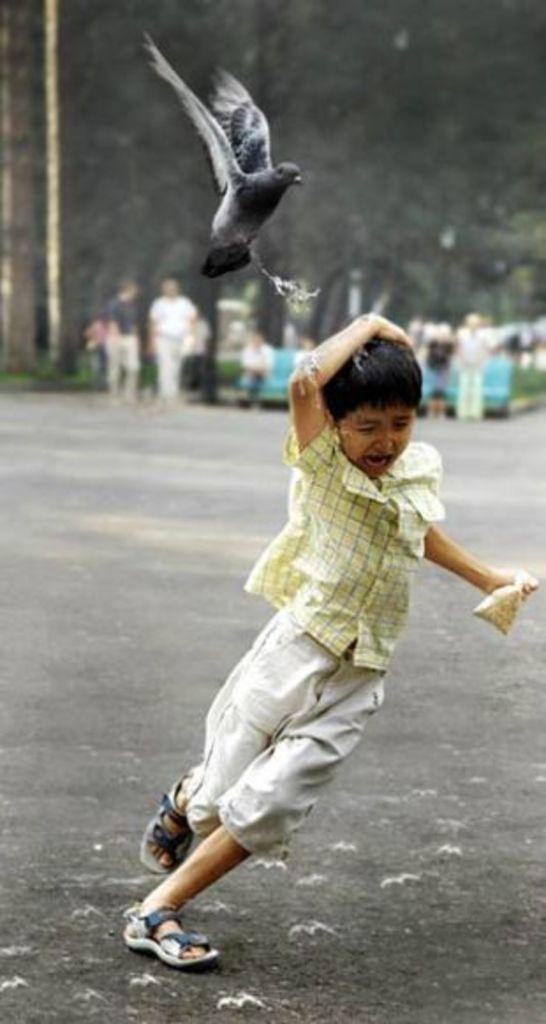What is the main subject of the image? The main subject of the image is a boy. What is the boy doing in the image? The boy is running on the road. What other living creature is present in the image? There is a bird in the image. Where is the bird located in relation to the boy? The bird is above the boy. What action is the bird performing in the image? The bird is emitting its excrement on the boy. Can you describe the background of the image? There are people standing in the background of the image. What type of meal is the boy eating in the image? There is no meal present in the image; the boy is running on the road. Can you describe the bedroom where the boy is sleeping in the image? There is no bedroom or sleeping boy in the image; the boy is running on the road. 